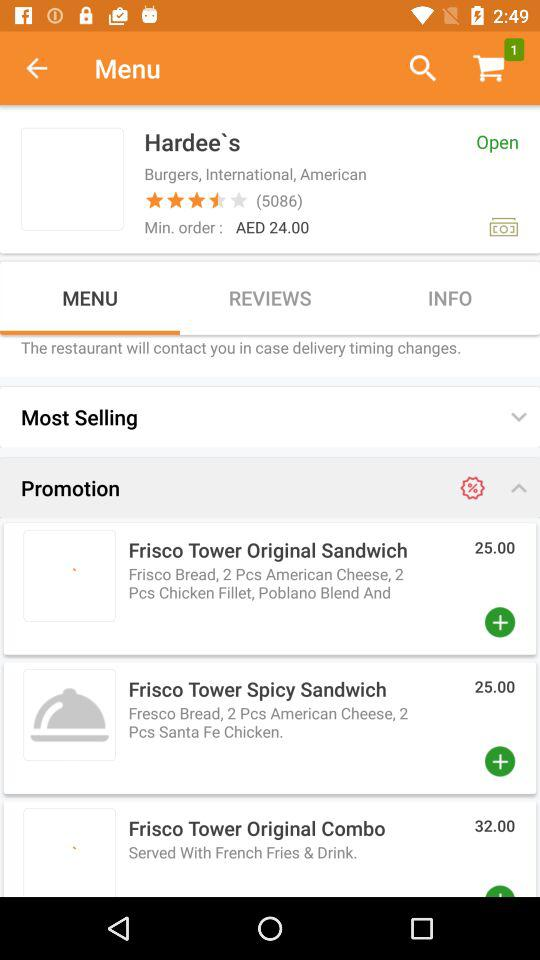Which tab is selected? The selected tab is "MENU". 